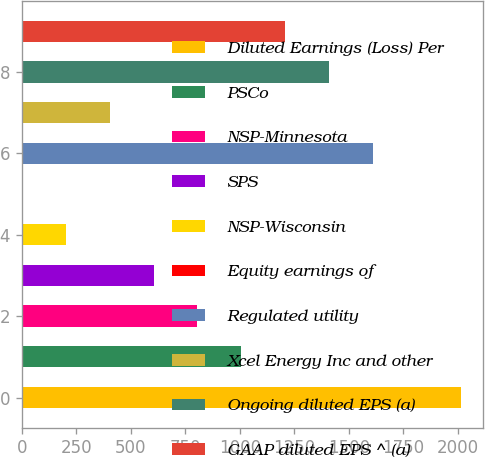Convert chart. <chart><loc_0><loc_0><loc_500><loc_500><bar_chart><fcel>Diluted Earnings (Loss) Per<fcel>PSCo<fcel>NSP-Minnesota<fcel>SPS<fcel>NSP-Wisconsin<fcel>Equity earnings of<fcel>Regulated utility<fcel>Xcel Energy Inc and other<fcel>Ongoing diluted EPS (a)<fcel>GAAP diluted EPS ^ (a)<nl><fcel>2013<fcel>1006.54<fcel>805.24<fcel>603.94<fcel>201.34<fcel>0.04<fcel>1610.44<fcel>402.64<fcel>1409.14<fcel>1207.84<nl></chart> 